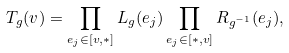<formula> <loc_0><loc_0><loc_500><loc_500>T _ { g } ( v ) = \prod _ { e _ { j } \in [ v , * ] } L _ { g } ( e _ { j } ) \prod _ { e _ { j } \in [ * , v ] } R _ { g ^ { - 1 } } ( e _ { j } ) ,</formula> 